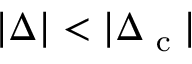Convert formula to latex. <formula><loc_0><loc_0><loc_500><loc_500>| \Delta | < | \Delta _ { c } |</formula> 